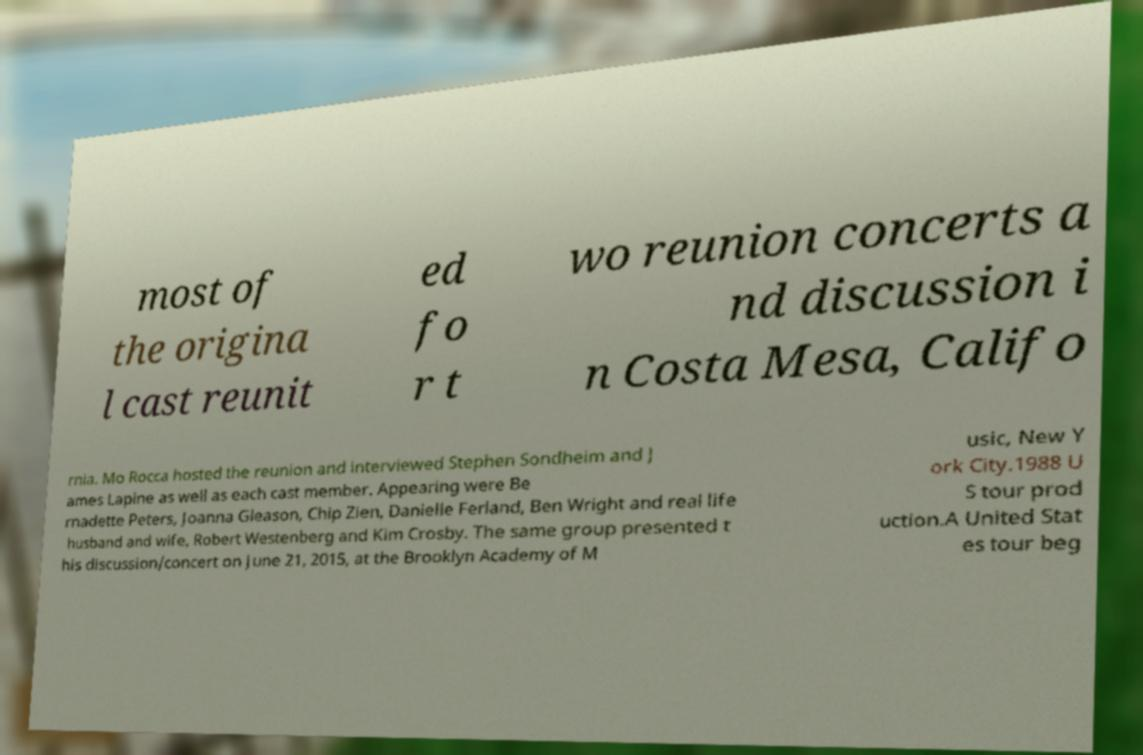Could you assist in decoding the text presented in this image and type it out clearly? most of the origina l cast reunit ed fo r t wo reunion concerts a nd discussion i n Costa Mesa, Califo rnia. Mo Rocca hosted the reunion and interviewed Stephen Sondheim and J ames Lapine as well as each cast member. Appearing were Be rnadette Peters, Joanna Gleason, Chip Zien, Danielle Ferland, Ben Wright and real life husband and wife, Robert Westenberg and Kim Crosby. The same group presented t his discussion/concert on June 21, 2015, at the Brooklyn Academy of M usic, New Y ork City.1988 U S tour prod uction.A United Stat es tour beg 